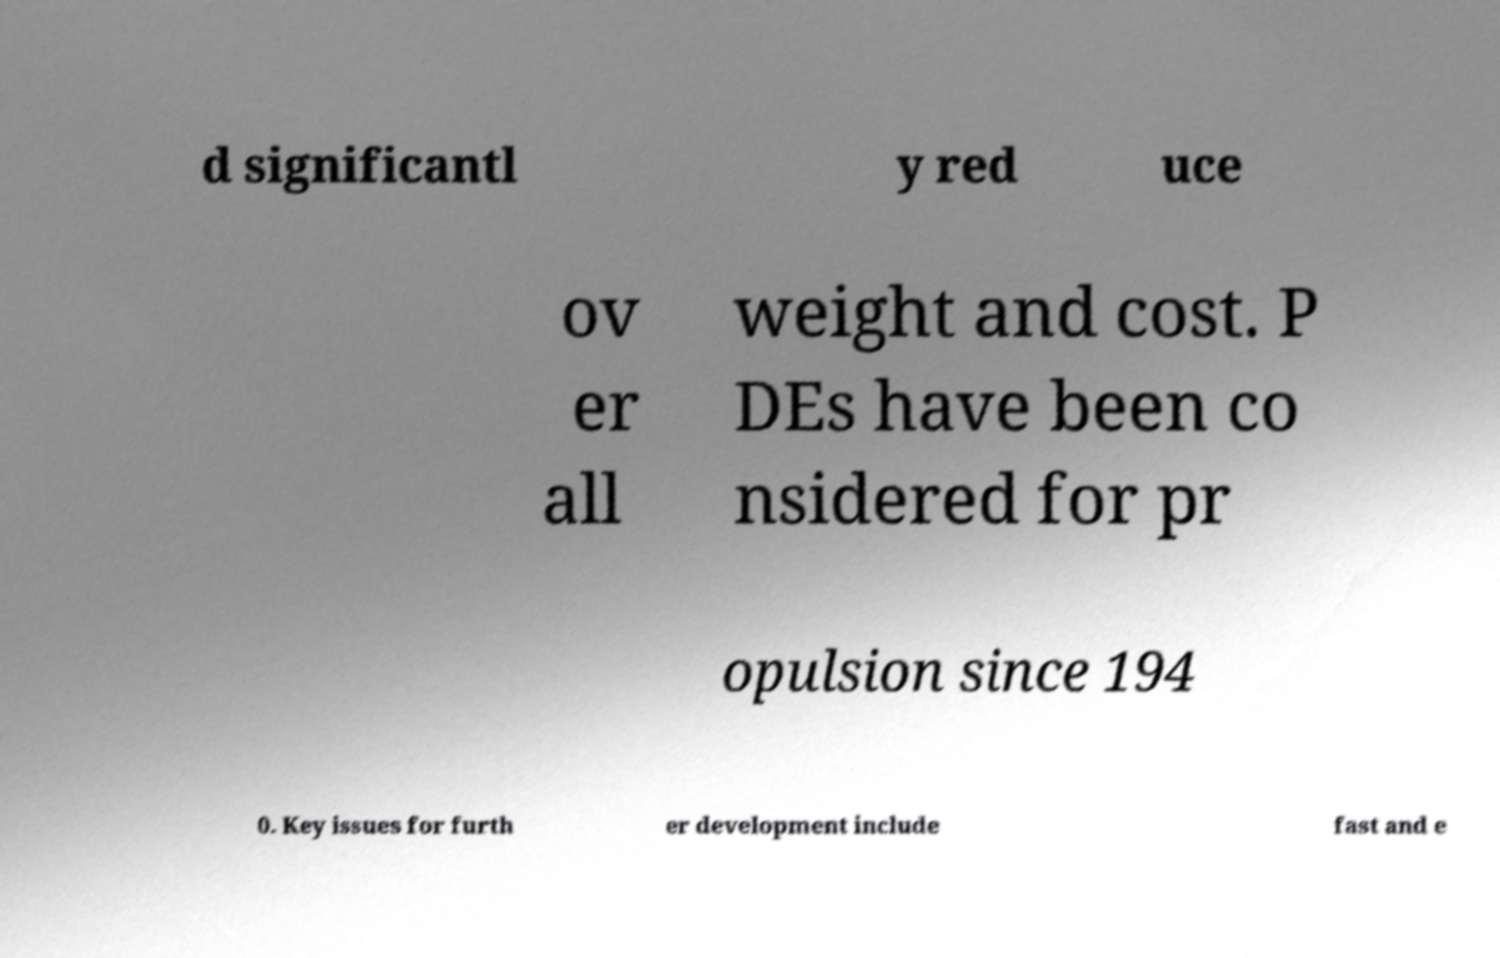What messages or text are displayed in this image? I need them in a readable, typed format. d significantl y red uce ov er all weight and cost. P DEs have been co nsidered for pr opulsion since 194 0. Key issues for furth er development include fast and e 